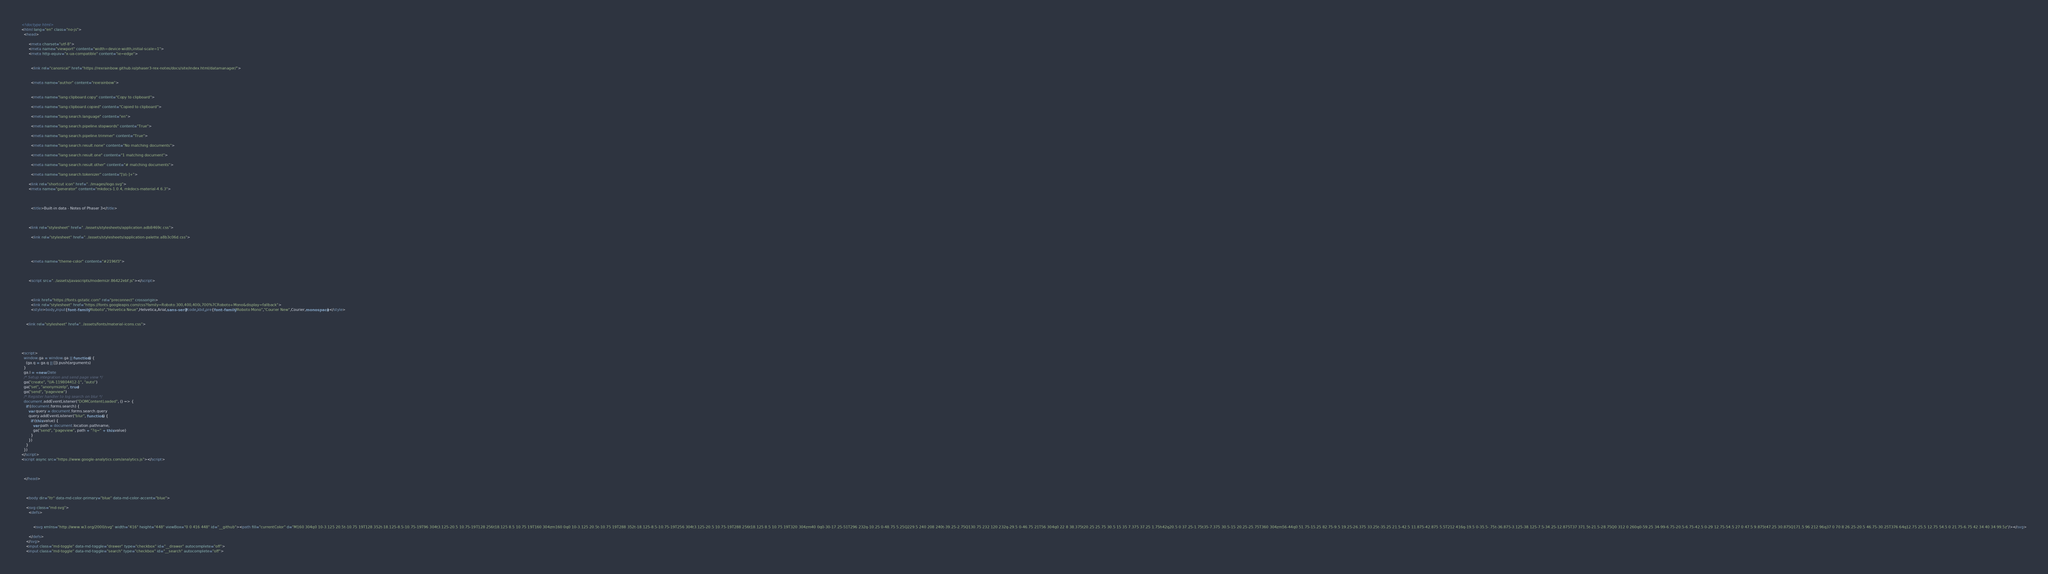Convert code to text. <code><loc_0><loc_0><loc_500><loc_500><_HTML_>



<!doctype html>
<html lang="en" class="no-js">
  <head>
    
      <meta charset="utf-8">
      <meta name="viewport" content="width=device-width,initial-scale=1">
      <meta http-equiv="x-ua-compatible" content="ie=edge">
      
      
        <link rel="canonical" href="https://rexrainbow.github.io/phaser3-rex-notes/docs/site/index.html/datamanager/">
      
      
        <meta name="author" content="rexrainbow">
      
      
        <meta name="lang:clipboard.copy" content="Copy to clipboard">
      
        <meta name="lang:clipboard.copied" content="Copied to clipboard">
      
        <meta name="lang:search.language" content="en">
      
        <meta name="lang:search.pipeline.stopwords" content="True">
      
        <meta name="lang:search.pipeline.trimmer" content="True">
      
        <meta name="lang:search.result.none" content="No matching documents">
      
        <meta name="lang:search.result.one" content="1 matching document">
      
        <meta name="lang:search.result.other" content="# matching documents">
      
        <meta name="lang:search.tokenizer" content="[\s\-]+">
      
      <link rel="shortcut icon" href="../images/logo.svg">
      <meta name="generator" content="mkdocs-1.0.4, mkdocs-material-4.6.3">
    
    
      
        <title>Built-in data - Notes of Phaser 3</title>
      
    
    
      <link rel="stylesheet" href="../assets/stylesheets/application.adb8469c.css">
      
        <link rel="stylesheet" href="../assets/stylesheets/application-palette.a8b3c06d.css">
      
      
        
        
        <meta name="theme-color" content="#2196f3">
      
    
    
      <script src="../assets/javascripts/modernizr.86422ebf.js"></script>
    
    
      
        <link href="https://fonts.gstatic.com" rel="preconnect" crossorigin>
        <link rel="stylesheet" href="https://fonts.googleapis.com/css?family=Roboto:300,400,400i,700%7CRoboto+Mono&display=fallback">
        <style>body,input{font-family:"Roboto","Helvetica Neue",Helvetica,Arial,sans-serif}code,kbd,pre{font-family:"Roboto Mono","Courier New",Courier,monospace}</style>
      
    
    <link rel="stylesheet" href="../assets/fonts/material-icons.css">
    
    
    
      
        
<script>
  window.ga = window.ga || function() {
    (ga.q = ga.q || []).push(arguments)
  }
  ga.l = +new Date
  /* Setup integration and send page view */
  ga("create", "UA-119804412-1", "auto")
  ga("set", "anonymizeIp", true)
  ga("send", "pageview")
  /* Register handler to log search on blur */
  document.addEventListener("DOMContentLoaded", () => {
    if (document.forms.search) {
      var query = document.forms.search.query
      query.addEventListener("blur", function() {
        if (this.value) {
          var path = document.location.pathname;
          ga("send", "pageview", path + "?q=" + this.value)
        }
      })
    }
  })
</script>
<script async src="https://www.google-analytics.com/analytics.js"></script>
      
    
    
  </head>
  
    
    
    <body dir="ltr" data-md-color-primary="blue" data-md-color-accent="blue">
  
    <svg class="md-svg">
      <defs>
        
        
          <svg xmlns="http://www.w3.org/2000/svg" width="416" height="448" viewBox="0 0 416 448" id="__github"><path fill="currentColor" d="M160 304q0 10-3.125 20.5t-10.75 19T128 352t-18.125-8.5-10.75-19T96 304t3.125-20.5 10.75-19T128 256t18.125 8.5 10.75 19T160 304zm160 0q0 10-3.125 20.5t-10.75 19T288 352t-18.125-8.5-10.75-19T256 304t3.125-20.5 10.75-19T288 256t18.125 8.5 10.75 19T320 304zm40 0q0-30-17.25-51T296 232q-10.25 0-48.75 5.25Q229.5 240 208 240t-39.25-2.75Q130.75 232 120 232q-29.5 0-46.75 21T56 304q0 22 8 38.375t20.25 25.75 30.5 15 35 7.375 37.25 1.75h42q20.5 0 37.25-1.75t35-7.375 30.5-15 20.25-25.75T360 304zm56-44q0 51.75-15.25 82.75-9.5 19.25-26.375 33.25t-35.25 21.5-42.5 11.875-42.875 5.5T212 416q-19.5 0-35.5-.75t-36.875-3.125-38.125-7.5-34.25-12.875T37 371.5t-21.5-28.75Q0 312 0 260q0-59.25 34-99-6.75-20.5-6.75-42.5 0-29 12.75-54.5 27 0 47.5 9.875t47.25 30.875Q171.5 96 212 96q37 0 70 8 26.25-20.5 46.75-30.25T376 64q12.75 25.5 12.75 54.5 0 21.75-6.75 42 34 40 34 99.5z"/></svg>
        
      </defs>
    </svg>
    <input class="md-toggle" data-md-toggle="drawer" type="checkbox" id="__drawer" autocomplete="off">
    <input class="md-toggle" data-md-toggle="search" type="checkbox" id="__search" autocomplete="off"></code> 